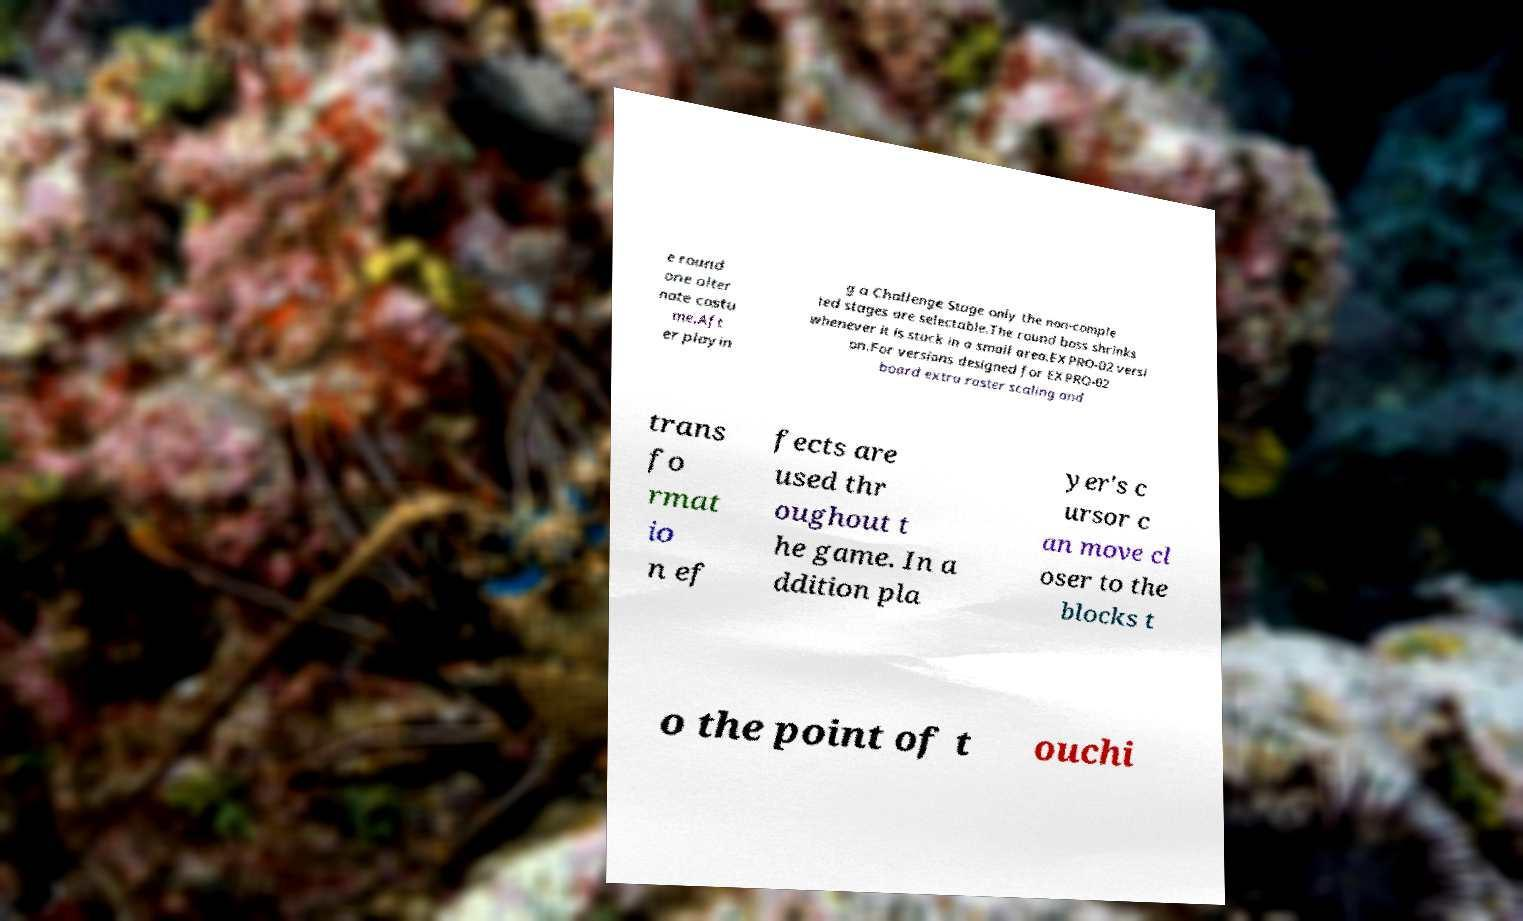For documentation purposes, I need the text within this image transcribed. Could you provide that? e round one alter nate costu me.Aft er playin g a Challenge Stage only the non-comple ted stages are selectable.The round boss shrinks whenever it is stuck in a small area.EXPRO-02 versi on.For versions designed for EXPRO-02 board extra raster scaling and trans fo rmat io n ef fects are used thr oughout t he game. In a ddition pla yer's c ursor c an move cl oser to the blocks t o the point of t ouchi 